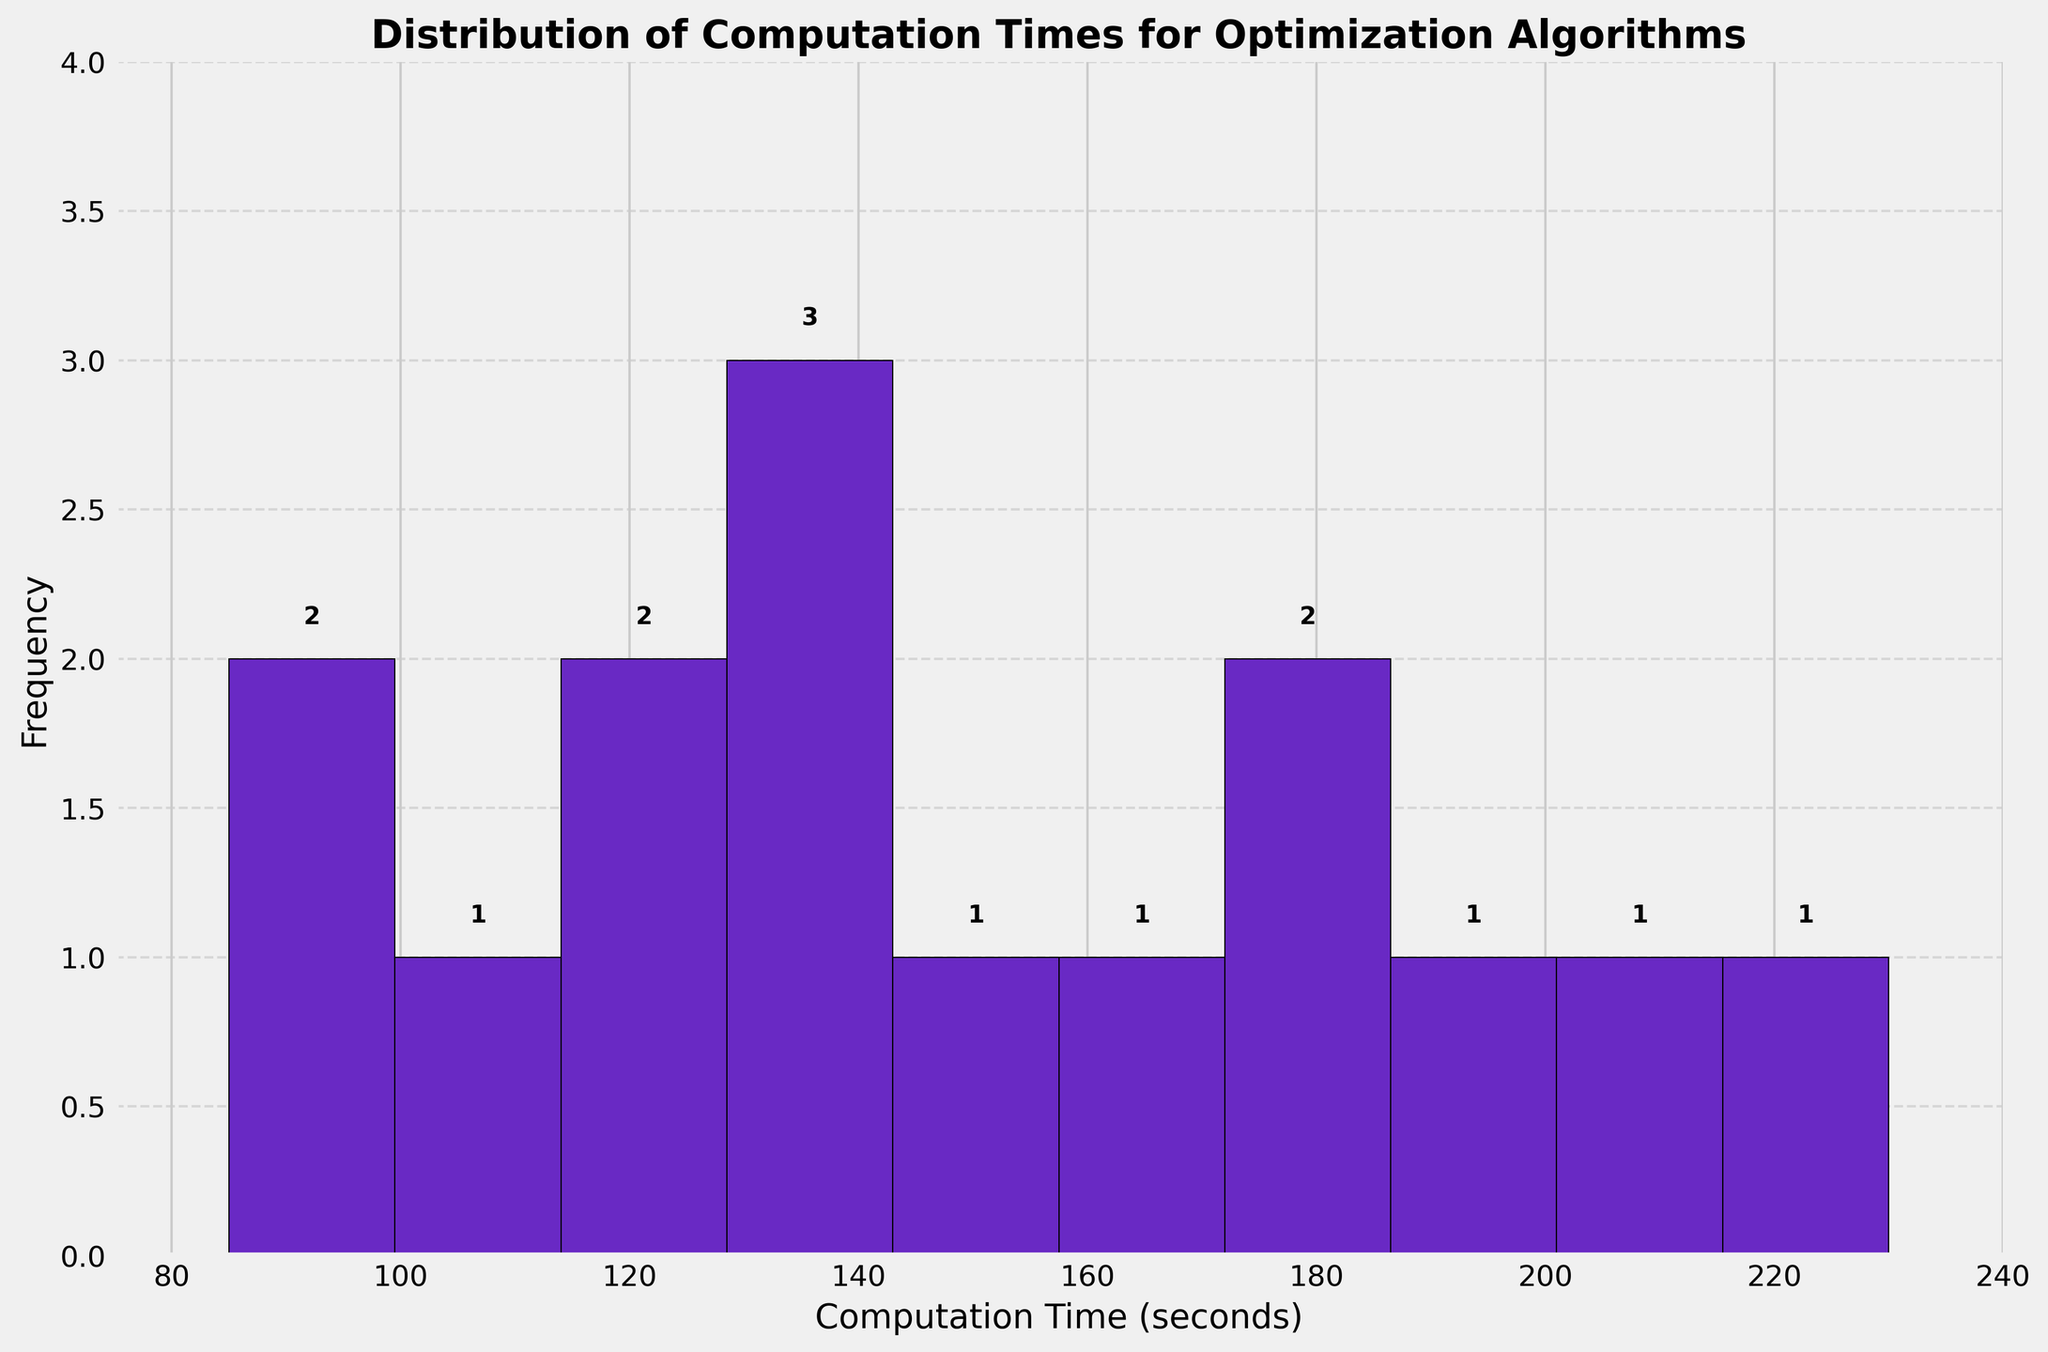What's the title of the plot? The title is usually found at the top of the plot and is often bolded. In this case, the title reads "Distribution of Computation Times for Optimization Algorithms".
Answer: Distribution of Computation Times for Optimization Algorithms What is plotted on the x-axis? The x-axis typically represents the interval or category being measured. Here, it represents "Computation Time (seconds)".
Answer: Computation Time (seconds) How many bins are used in this histogram? To find the number of bins, one can count the number of intervals on the x-axis. In this plot, there are ten bins.
Answer: 10 Which bin has the highest frequency? From the histogram, the highest frequency can be identified by the tallest bar. The bin between 90 and 110 seconds has the highest frequency.
Answer: 90-110 seconds What's the range of the x-axis? The range can be observed from the minimum and maximum values shown along the x-axis. Here, the range is from just below 85 seconds to just above 230 seconds.
Answer: 85 to 230 seconds What is the frequency of the bin containing computation times between 90 and 110 seconds? By looking at the height of the bar that spans 90-110 seconds, and also the number placed above the bar, we see that the frequency is 3.
Answer: 3 How many computation times are greater than 200 seconds? From the histogram, we can see that one bin covers the range from 200 to 220. The height of this bar, and the number above it, indicates a frequency of 2.
Answer: 2 What is the average computation time for the optimization algorithms? Summing each computation time (120 + 85 + 210 + 175 + 145 + 230 + 95 + 130 + 105 + 140 + 115 + 200 + 160 + 135 + 180 = 2330) and dividing by the number of algorithms (15) gives the average: 2330 / 15 = 155.33 seconds.
Answer: 155.33 seconds Which computation time represents the median? Arranging the computation times in ascending order: 85, 95, 105, 115, 120, 130, 135, 140, 145, 160, 175, 180, 200, 210, 230, and finding the middle value. With 15 data points, the 8th value is the median: 140 seconds.
Answer: 140 seconds How many algorithms fall within the computation time range of 130-160 seconds? The bin that covers 130-160 seconds shows a combined data frequency found by adding the individual frequencies from the bars within this range. Bins covering 130-150 and 150-170 seconds include 3+2 = 5 algorithms.
Answer: 5 algorithms 